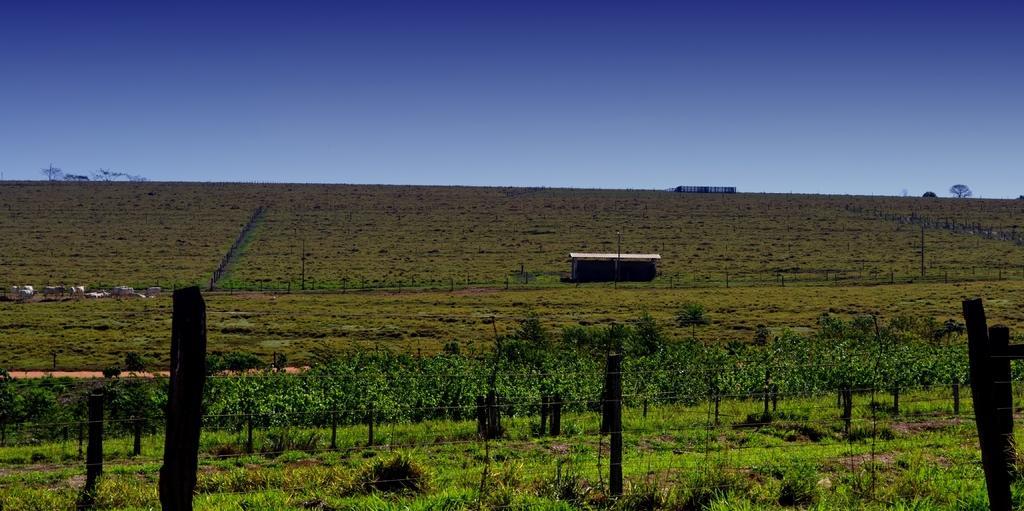In one or two sentences, can you explain what this image depicts? In this image I can see plants, the grass, animals, fence and poles. In the background I can see trees and the sky. 